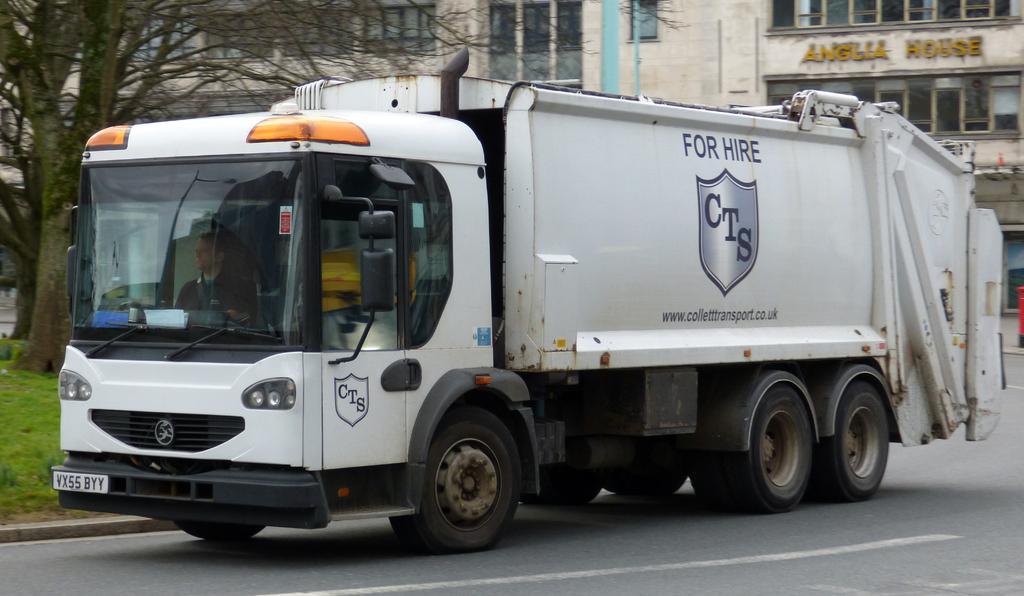In one or two sentences, can you explain what this image depicts? There is a truck on the road as we can see in the middle of this image. There is a building and a tree in the background. 